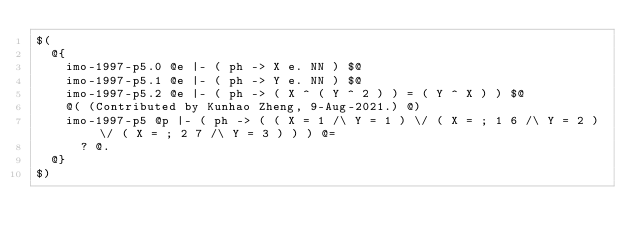<code> <loc_0><loc_0><loc_500><loc_500><_ObjectiveC_>$(
  @{
    imo-1997-p5.0 @e |- ( ph -> X e. NN ) $@
    imo-1997-p5.1 @e |- ( ph -> Y e. NN ) $@
    imo-1997-p5.2 @e |- ( ph -> ( X ^ ( Y ^ 2 ) ) = ( Y ^ X ) ) $@
    @( (Contributed by Kunhao Zheng, 9-Aug-2021.) @)
    imo-1997-p5 @p |- ( ph -> ( ( X = 1 /\ Y = 1 ) \/ ( X = ; 1 6 /\ Y = 2 ) \/ ( X = ; 2 7 /\ Y = 3 ) ) ) @=
      ? @.
  @}
$)
</code> 